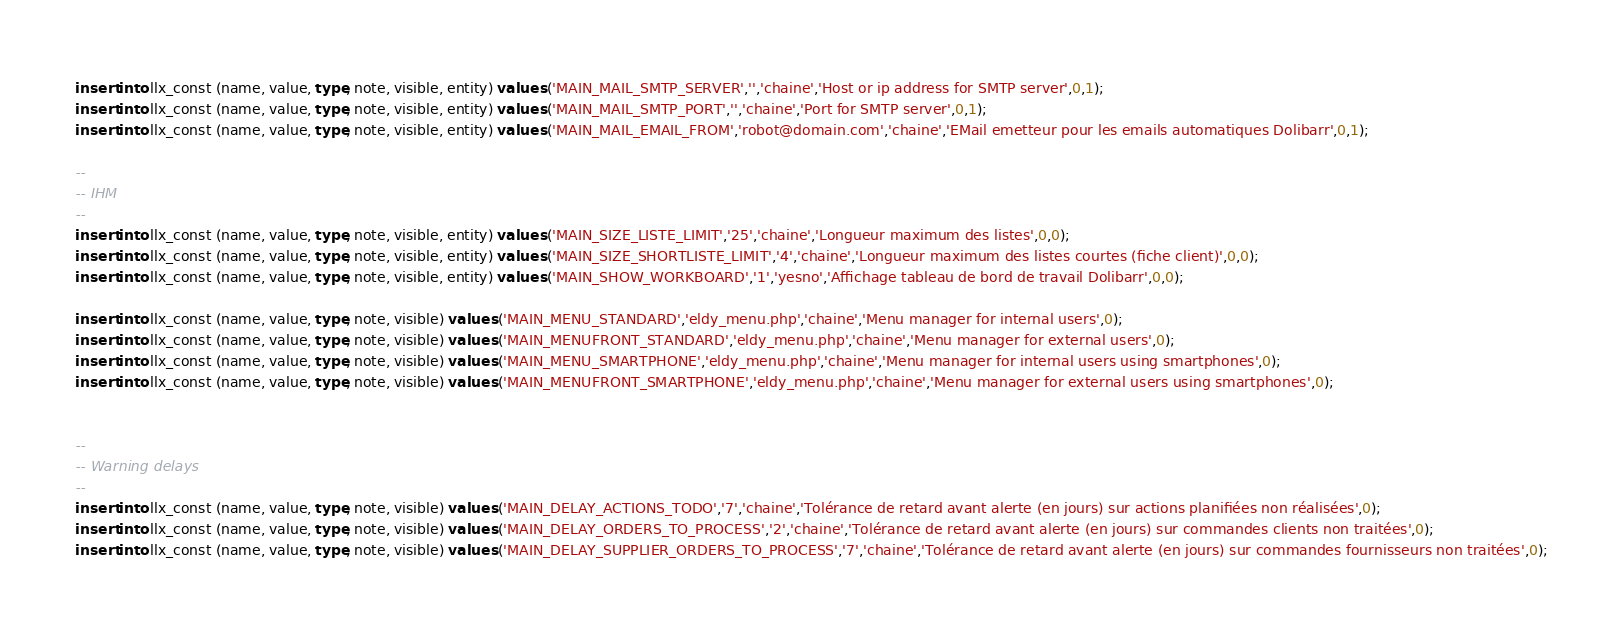Convert code to text. <code><loc_0><loc_0><loc_500><loc_500><_SQL_>
insert into llx_const (name, value, type, note, visible, entity) values ('MAIN_MAIL_SMTP_SERVER','','chaine','Host or ip address for SMTP server',0,1);
insert into llx_const (name, value, type, note, visible, entity) values ('MAIN_MAIL_SMTP_PORT','','chaine','Port for SMTP server',0,1);
insert into llx_const (name, value, type, note, visible, entity) values ('MAIN_MAIL_EMAIL_FROM','robot@domain.com','chaine','EMail emetteur pour les emails automatiques Dolibarr',0,1);

--
-- IHM
--
insert into llx_const (name, value, type, note, visible, entity) values ('MAIN_SIZE_LISTE_LIMIT','25','chaine','Longueur maximum des listes',0,0);
insert into llx_const (name, value, type, note, visible, entity) values ('MAIN_SIZE_SHORTLISTE_LIMIT','4','chaine','Longueur maximum des listes courtes (fiche client)',0,0);
insert into llx_const (name, value, type, note, visible, entity) values ('MAIN_SHOW_WORKBOARD','1','yesno','Affichage tableau de bord de travail Dolibarr',0,0);

insert into llx_const (name, value, type, note, visible) values ('MAIN_MENU_STANDARD','eldy_menu.php','chaine','Menu manager for internal users',0);
insert into llx_const (name, value, type, note, visible) values ('MAIN_MENUFRONT_STANDARD','eldy_menu.php','chaine','Menu manager for external users',0);
insert into llx_const (name, value, type, note, visible) values ('MAIN_MENU_SMARTPHONE','eldy_menu.php','chaine','Menu manager for internal users using smartphones',0);
insert into llx_const (name, value, type, note, visible) values ('MAIN_MENUFRONT_SMARTPHONE','eldy_menu.php','chaine','Menu manager for external users using smartphones',0);


--
-- Warning delays
--
insert into llx_const (name, value, type, note, visible) values ('MAIN_DELAY_ACTIONS_TODO','7','chaine','Tolérance de retard avant alerte (en jours) sur actions planifiées non réalisées',0);
insert into llx_const (name, value, type, note, visible) values ('MAIN_DELAY_ORDERS_TO_PROCESS','2','chaine','Tolérance de retard avant alerte (en jours) sur commandes clients non traitées',0);
insert into llx_const (name, value, type, note, visible) values ('MAIN_DELAY_SUPPLIER_ORDERS_TO_PROCESS','7','chaine','Tolérance de retard avant alerte (en jours) sur commandes fournisseurs non traitées',0);</code> 